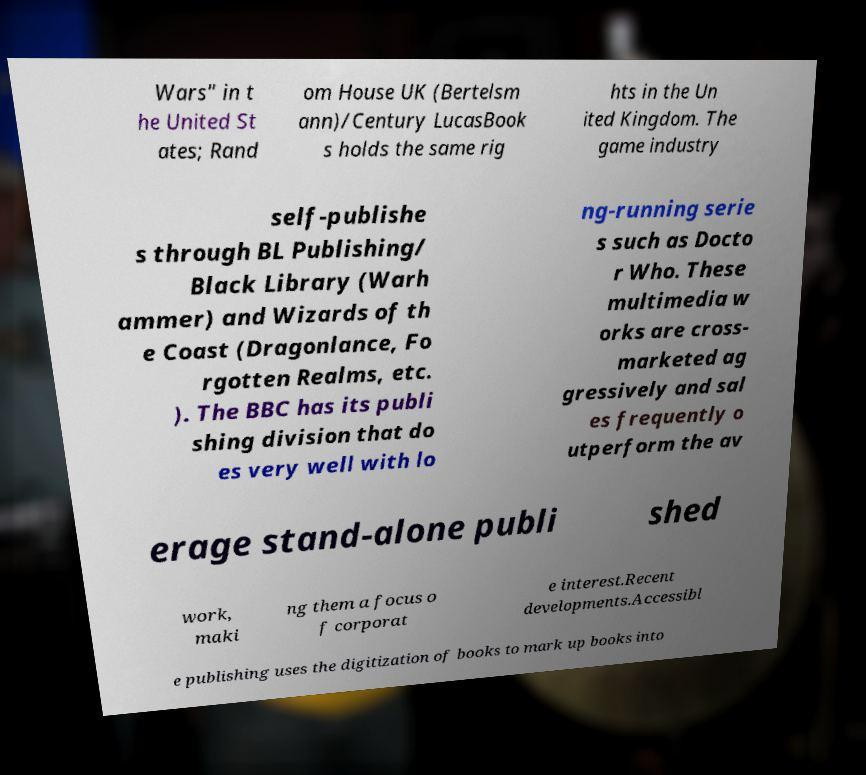There's text embedded in this image that I need extracted. Can you transcribe it verbatim? Wars" in t he United St ates; Rand om House UK (Bertelsm ann)/Century LucasBook s holds the same rig hts in the Un ited Kingdom. The game industry self-publishe s through BL Publishing/ Black Library (Warh ammer) and Wizards of th e Coast (Dragonlance, Fo rgotten Realms, etc. ). The BBC has its publi shing division that do es very well with lo ng-running serie s such as Docto r Who. These multimedia w orks are cross- marketed ag gressively and sal es frequently o utperform the av erage stand-alone publi shed work, maki ng them a focus o f corporat e interest.Recent developments.Accessibl e publishing uses the digitization of books to mark up books into 